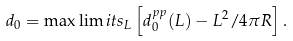<formula> <loc_0><loc_0><loc_500><loc_500>d _ { 0 } = \max \lim i t s _ { L } \left [ d _ { 0 } ^ { p p } ( L ) - L ^ { 2 } / 4 \pi R \right ] .</formula> 